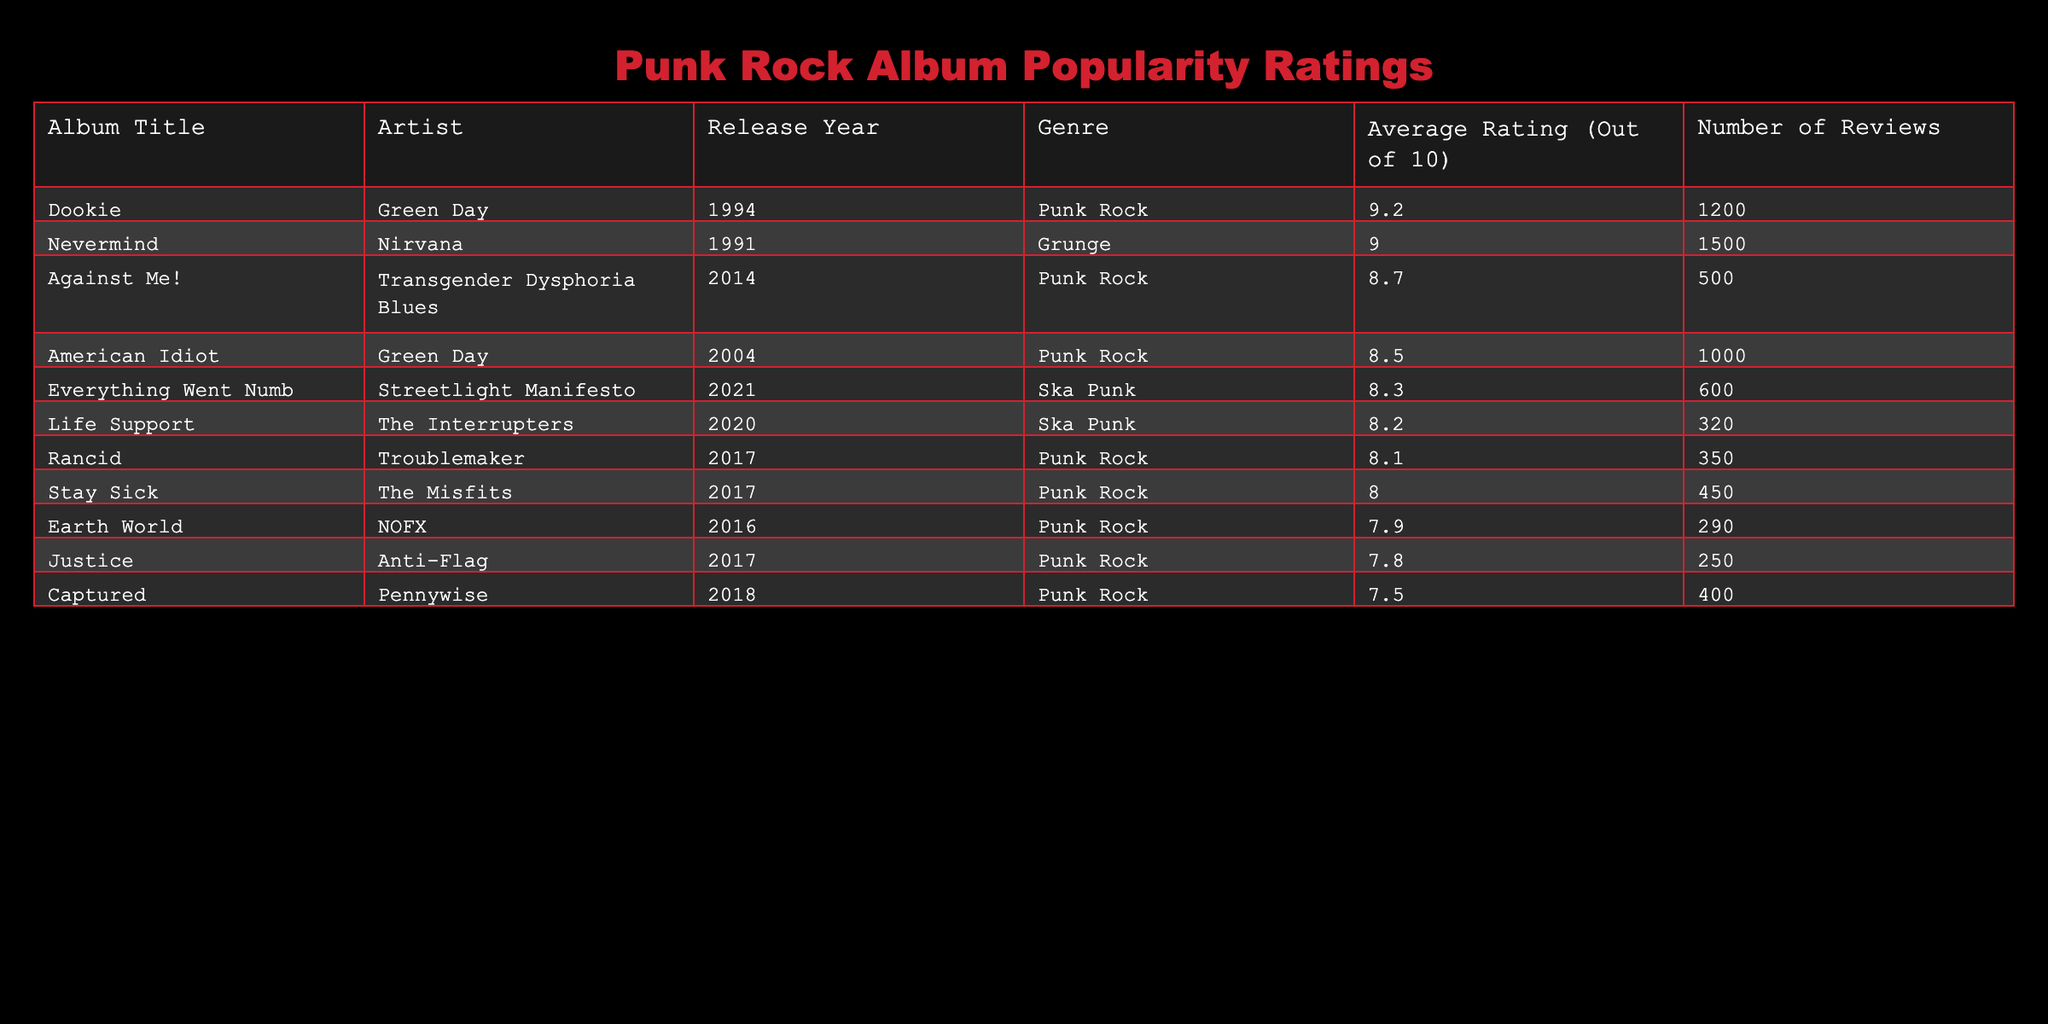What is the highest average rating in the table? The table shows the average ratings of various albums. Scanning through the "Average Rating (Out of 10)" column, I see that "Dookie" by Green Day has the highest average rating of 9.2.
Answer: 9.2 Which album received the most reviews? Looking at the "Number of Reviews" column, the album "Dookie" by Green Day has the highest number of reviews listed as 1200.
Answer: 1200 How many more reviews did "American Idiot" have than "Captured"? The number of reviews for "American Idiot" is 1000 and for "Captured" is 400. Subtracting these gives: 1000 - 400 = 600, so "American Idiot" received 600 more reviews than "Captured."
Answer: 600 Is the average rating of "Stay Sick" higher than "Justice"? The average rating for "Stay Sick" is 8.0 and for "Justice" it is 7.8. Since 8.0 is greater than 7.8, "Stay Sick" does have a higher rating.
Answer: Yes What is the average rating of the Ska Punk albums listed in the table? The Ska Punk albums are "Life Support" with a rating of 8.2 and "Everything Went Numb" with a rating of 8.3. To find the average, I add these ratings: 8.2 + 8.3 = 16.5. Then divide by 2, which gives: 16.5 / 2 = 8.25. Thus, the average rating is 8.25.
Answer: 8.25 Which artist has the most albums listed in the table? Scanning through the "Artist" column, I notice Green Day appears with two albums: "American Idiot" and "Dookie," while all other artists have one album listed. Therefore, Green Day is the artist with the most albums in the table.
Answer: Green Day Did more than half of the albums have an average rating above 8.0? Out of the total 10 albums: "American Idiot" (8.5), "Stay Sick" (8.0), "Life Support" (8.2), "Against Me!" (8.7), "Rancid" (8.1), and "Everything Went Numb" (8.3) have ratings above 8.0, making it 6 albums. Since 6 is more than half of 10, the statement is true.
Answer: Yes What is the median average rating of all the punk rock albums listed? To find the median, I first list the average ratings of the punk rock albums: 8.5, 8.0, 7.8, 7.5, 8.7, 8.1, 7.9. When arranged in ascending order, we have 7.5, 7.8, 7.9, 8.0, 8.1, 8.5, 8.7. With 7 ratings, the median is the fourth rating which is 8.0.
Answer: 8.0 How many albums have an average rating below 8.0? The albums that have average ratings below 8.0 are "Captured" at 7.5, "Justice" at 7.8, and "Earth World" at 7.9. Counting these gives 3 albums with ratings below 8.0.
Answer: 3 